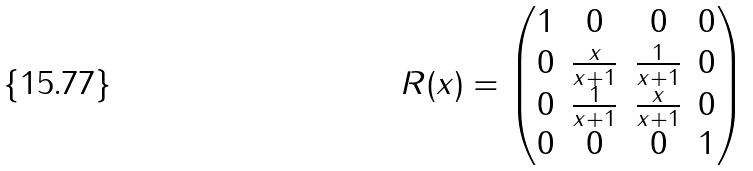<formula> <loc_0><loc_0><loc_500><loc_500>R ( x ) = \begin{pmatrix} 1 & 0 & 0 & 0 \\ 0 & \frac { x } { x + 1 } & \frac { 1 } { x + 1 } & 0 \\ 0 & \frac { 1 } { x + 1 } & \frac { x } { x + 1 } & 0 \\ 0 & 0 & 0 & 1 \end{pmatrix}</formula> 